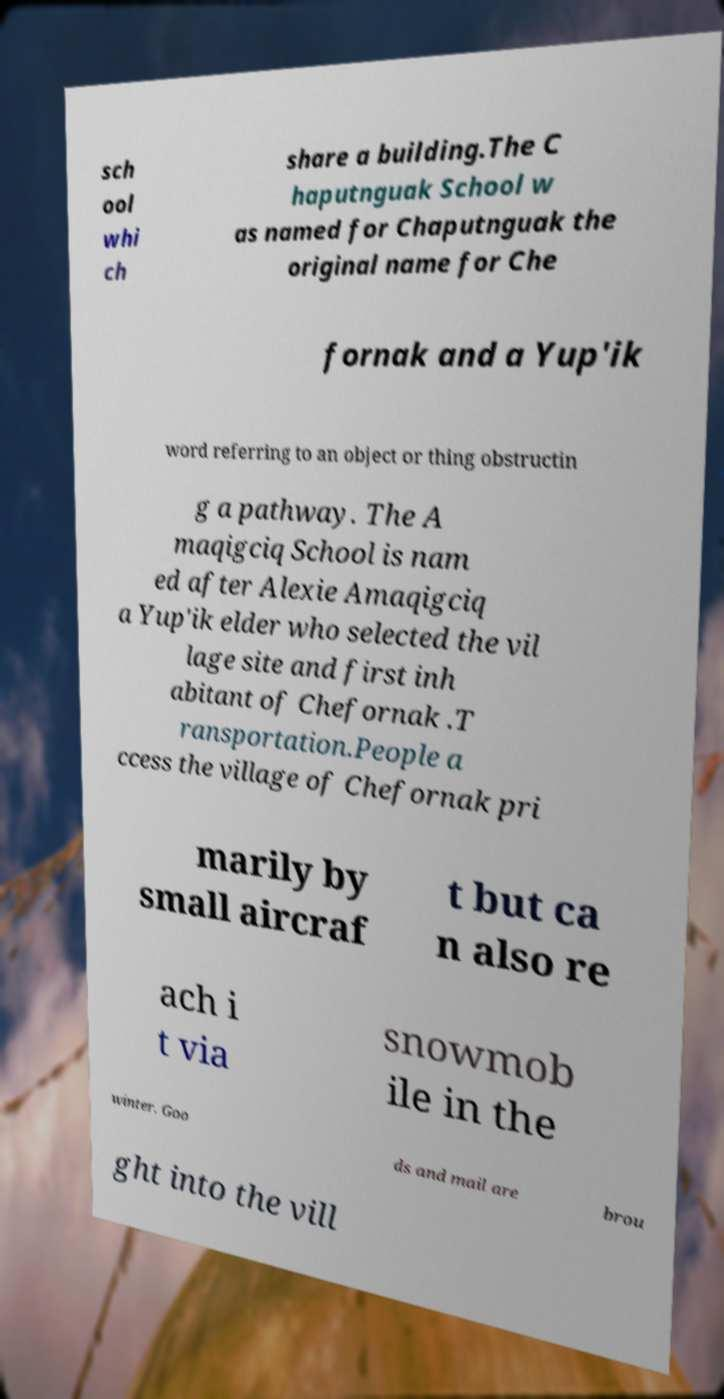Could you extract and type out the text from this image? sch ool whi ch share a building.The C haputnguak School w as named for Chaputnguak the original name for Che fornak and a Yup'ik word referring to an object or thing obstructin g a pathway. The A maqigciq School is nam ed after Alexie Amaqigciq a Yup'ik elder who selected the vil lage site and first inh abitant of Chefornak .T ransportation.People a ccess the village of Chefornak pri marily by small aircraf t but ca n also re ach i t via snowmob ile in the winter. Goo ds and mail are brou ght into the vill 